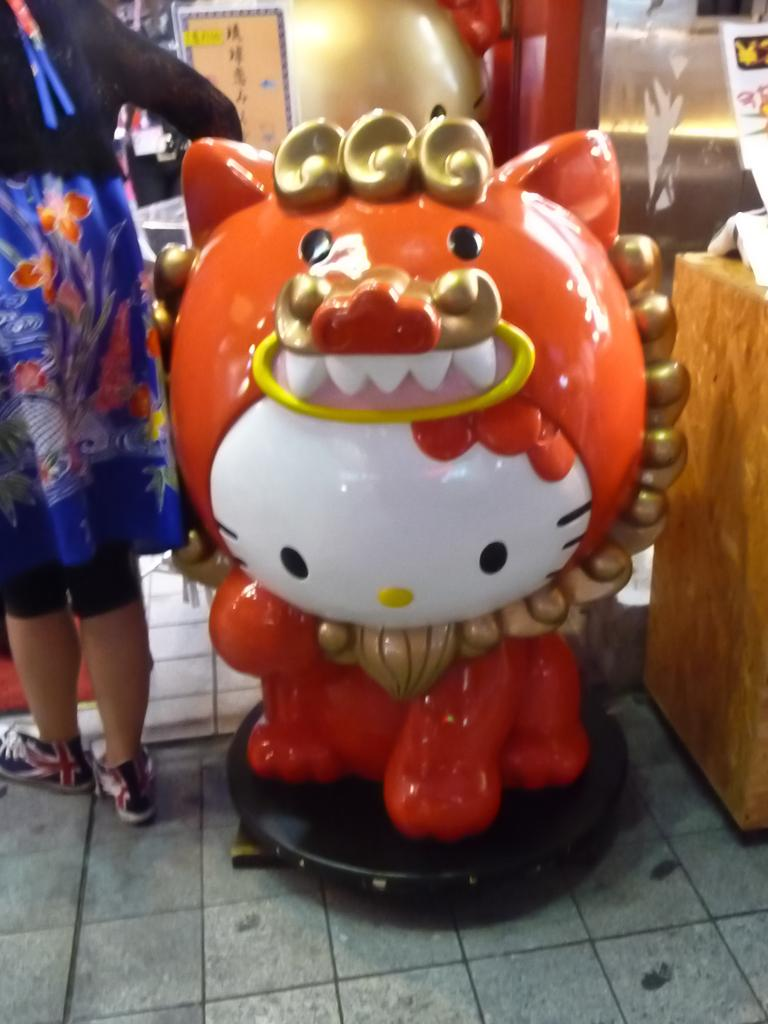What is the main subject of the image? There is a statue of Hello Kitty in the image. How is the Hello Kitty statue positioned in the image? The statue is standing on a small platform. Is there anyone else present in the image besides the statue? Yes, there is a person standing beside the statue. Can you tell me how many snails are crawling on the swing in the image? There are no snails or swings present in the image; it features a statue of Hello Kitty standing on a small platform with a person beside it. 